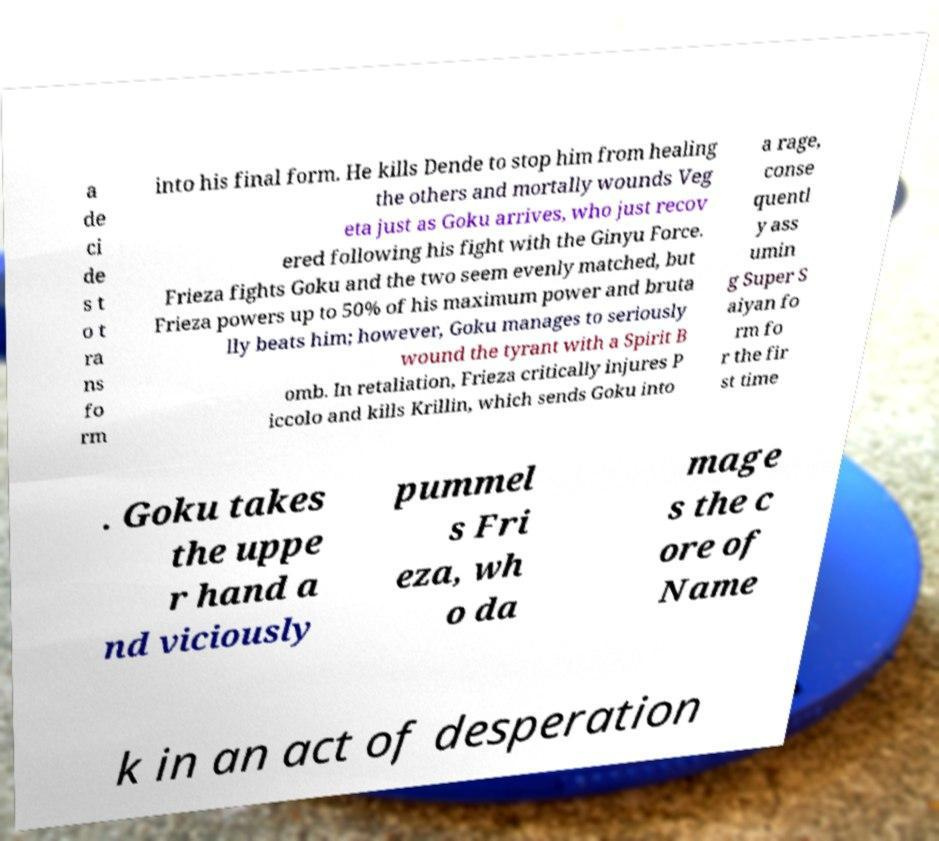Can you accurately transcribe the text from the provided image for me? a de ci de s t o t ra ns fo rm into his final form. He kills Dende to stop him from healing the others and mortally wounds Veg eta just as Goku arrives, who just recov ered following his fight with the Ginyu Force. Frieza fights Goku and the two seem evenly matched, but Frieza powers up to 50% of his maximum power and bruta lly beats him; however, Goku manages to seriously wound the tyrant with a Spirit B omb. In retaliation, Frieza critically injures P iccolo and kills Krillin, which sends Goku into a rage, conse quentl y ass umin g Super S aiyan fo rm fo r the fir st time . Goku takes the uppe r hand a nd viciously pummel s Fri eza, wh o da mage s the c ore of Name k in an act of desperation 